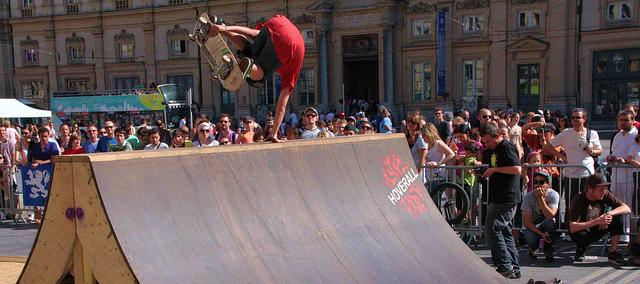What maneuver is the man wearing red performing?

Choices:
A) grind
B) front spin
C) hand plant
D) big air hand plant 